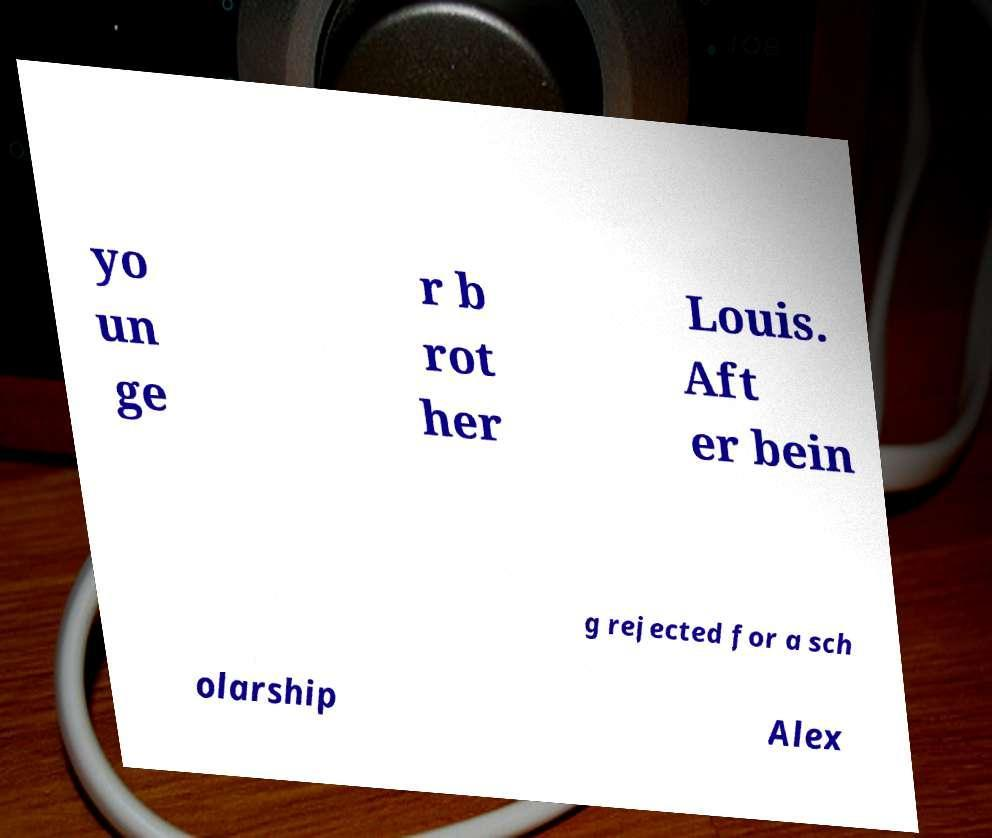Could you assist in decoding the text presented in this image and type it out clearly? yo un ge r b rot her Louis. Aft er bein g rejected for a sch olarship Alex 